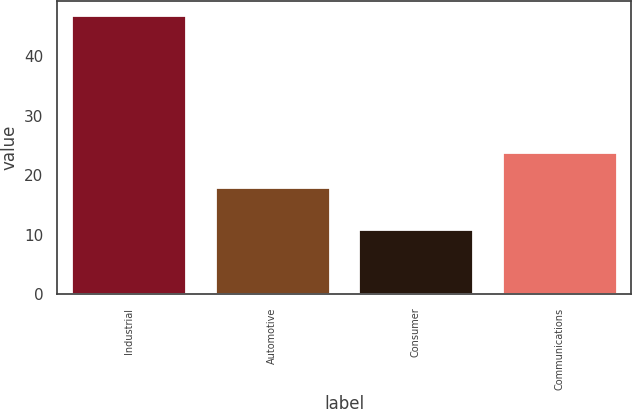<chart> <loc_0><loc_0><loc_500><loc_500><bar_chart><fcel>Industrial<fcel>Automotive<fcel>Consumer<fcel>Communications<nl><fcel>47<fcel>18<fcel>11<fcel>24<nl></chart> 